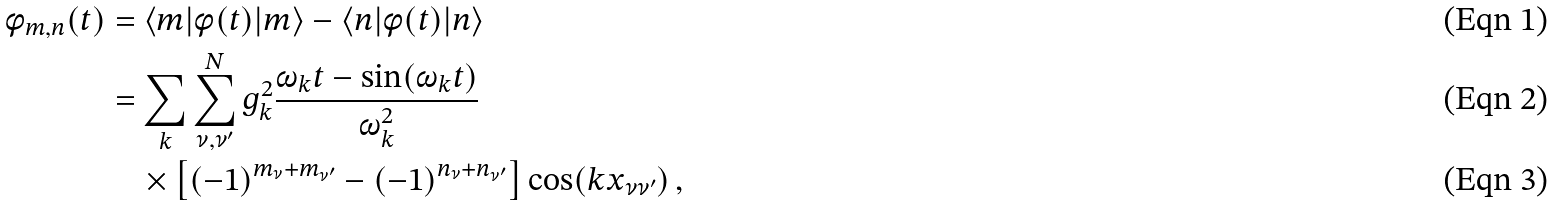<formula> <loc_0><loc_0><loc_500><loc_500>\phi _ { m , n } ( t ) & = \langle m | \phi ( t ) | m \rangle - \langle n | \phi ( t ) | n \rangle \\ & = \sum _ { k } \sum _ { \nu , \nu ^ { \prime } } ^ { N } g ^ { 2 } _ { k } \frac { \omega _ { k } t - \sin ( \omega _ { k } t ) } { \omega _ { k } ^ { 2 } } \\ & \quad \times \left [ ( - 1 ) ^ { m _ { \nu } + m _ { \nu ^ { \prime } } } - ( - 1 ) ^ { n _ { \nu } + n _ { \nu ^ { \prime } } } \right ] \cos ( k x _ { \nu \nu ^ { \prime } } ) \, ,</formula> 